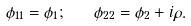<formula> <loc_0><loc_0><loc_500><loc_500>\phi _ { 1 1 } = \phi _ { 1 } ; \quad \phi _ { 2 2 } = \phi _ { 2 } + i \rho .</formula> 